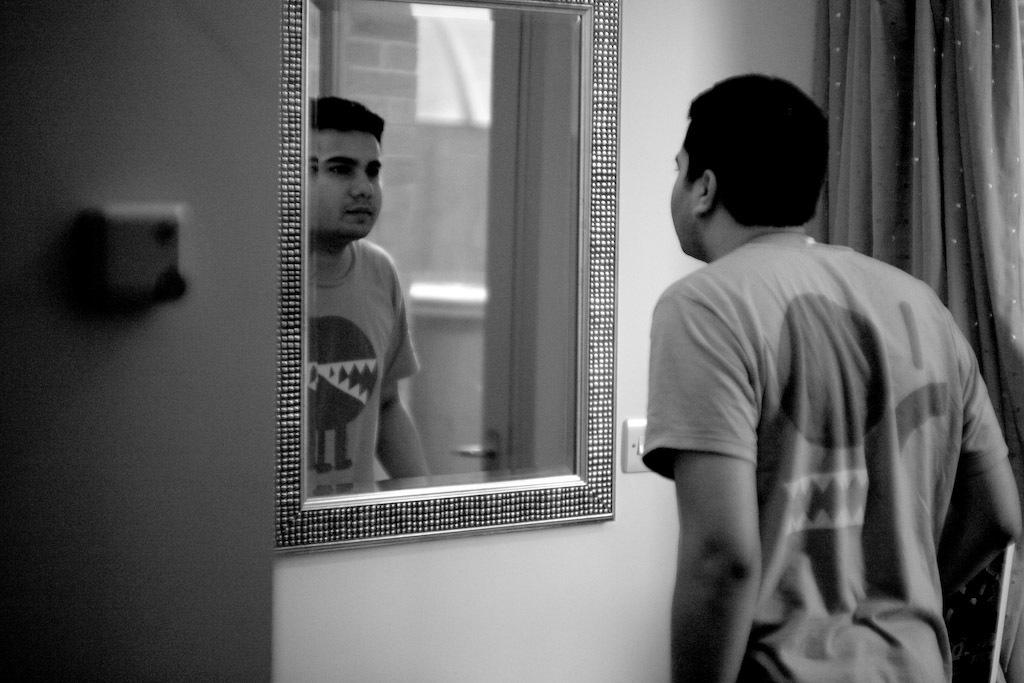What is the man doing in the image? The man is looking in the mirror. What can be seen on the wall in the image? There is a switch board on the wall. What is located beside the man in the image? There is a curtain beside the man. How much money does the man have in his hand in the image? There is no indication of money or any financial transaction in the image. --- Facts: 1. There is a group of people standing in a circle. 2. They are holding hands. 3. There is a tree in the background. 4. The sky is visible in the image. Absurd Topics: dance, ocean, bicycle Conversation: What are the people in the image doing? The people in the image are standing in a circle and holding hands. What can be seen in the background of the image? There is a tree in the background. What is visible at the top of the image? The sky is visible in the image. Reasoning: Let's think step by step in order to produce the conversation. We start by identifying the main subject in the image, which is the group of people standing in a circle and holding hands. Then, we expand the conversation to include other elements in the image, such as the tree in the background and the sky visible at the top. Each question is designed to elicit a specific detail about the image that is known from the provided facts. Absurd Question/Answer: Can you see the ocean in the background of the image? No, there is no ocean visible in the image; only a tree and the sky are present in the background. 